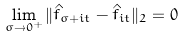<formula> <loc_0><loc_0><loc_500><loc_500>\lim _ { \sigma \to 0 ^ { + } } \| \hat { f } _ { \sigma + i t } - \hat { f } _ { i t } \| _ { 2 } = 0</formula> 